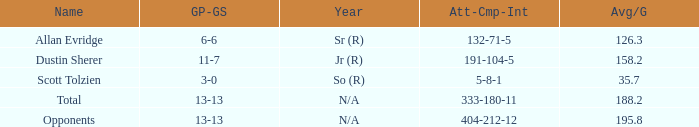Who is the quarterback with an avg/g of 195.8 yards? Opponents. 